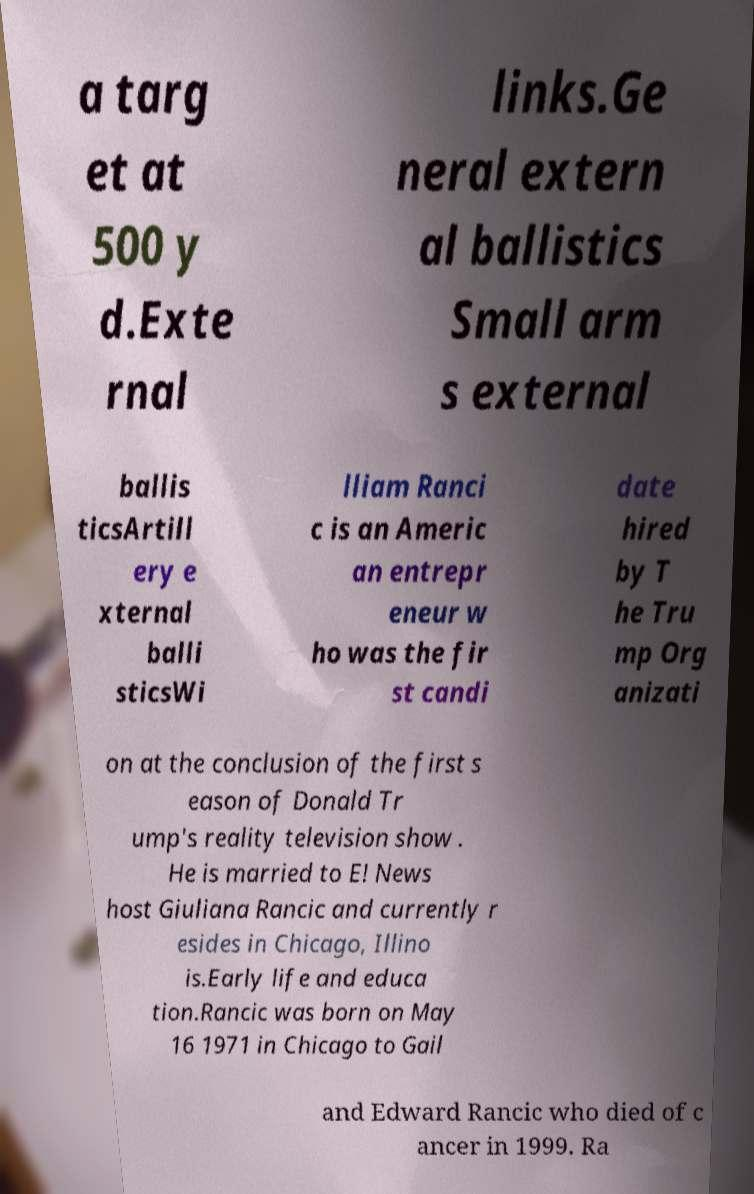Can you accurately transcribe the text from the provided image for me? a targ et at 500 y d.Exte rnal links.Ge neral extern al ballistics Small arm s external ballis ticsArtill ery e xternal balli sticsWi lliam Ranci c is an Americ an entrepr eneur w ho was the fir st candi date hired by T he Tru mp Org anizati on at the conclusion of the first s eason of Donald Tr ump's reality television show . He is married to E! News host Giuliana Rancic and currently r esides in Chicago, Illino is.Early life and educa tion.Rancic was born on May 16 1971 in Chicago to Gail and Edward Rancic who died of c ancer in 1999. Ra 